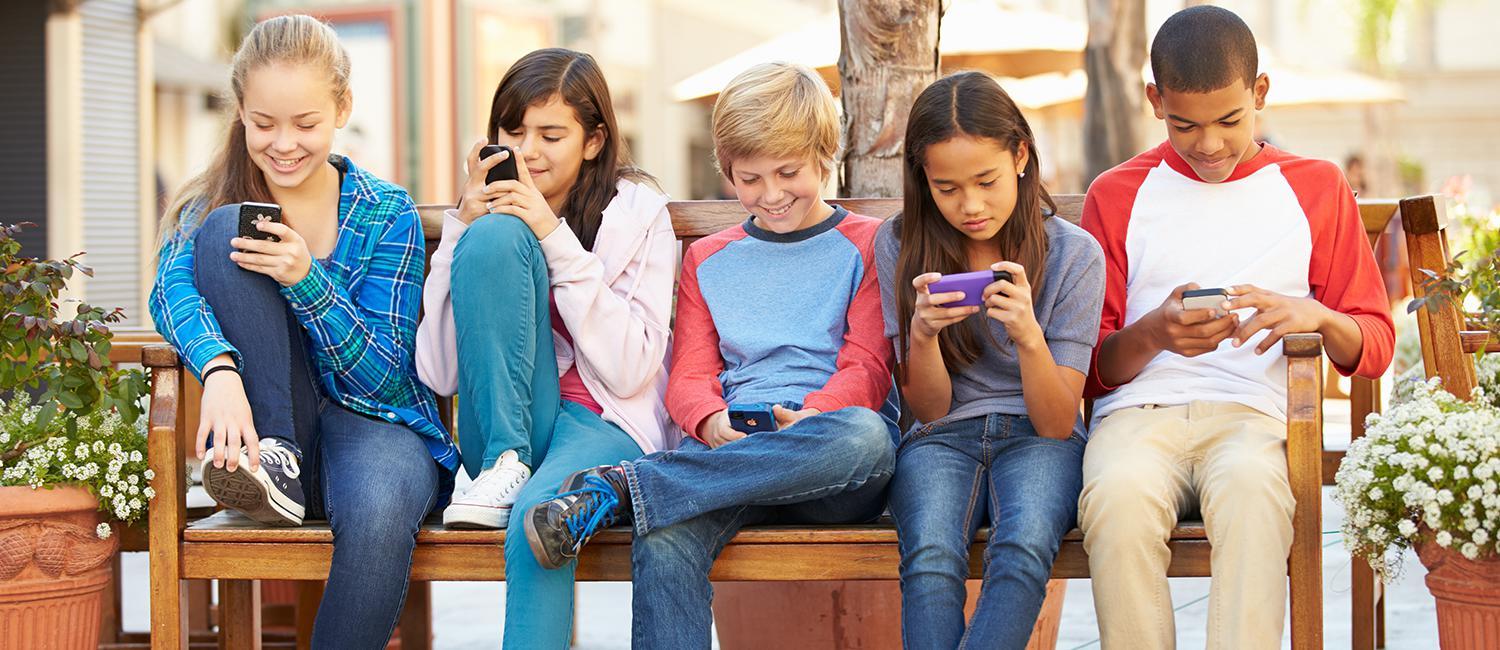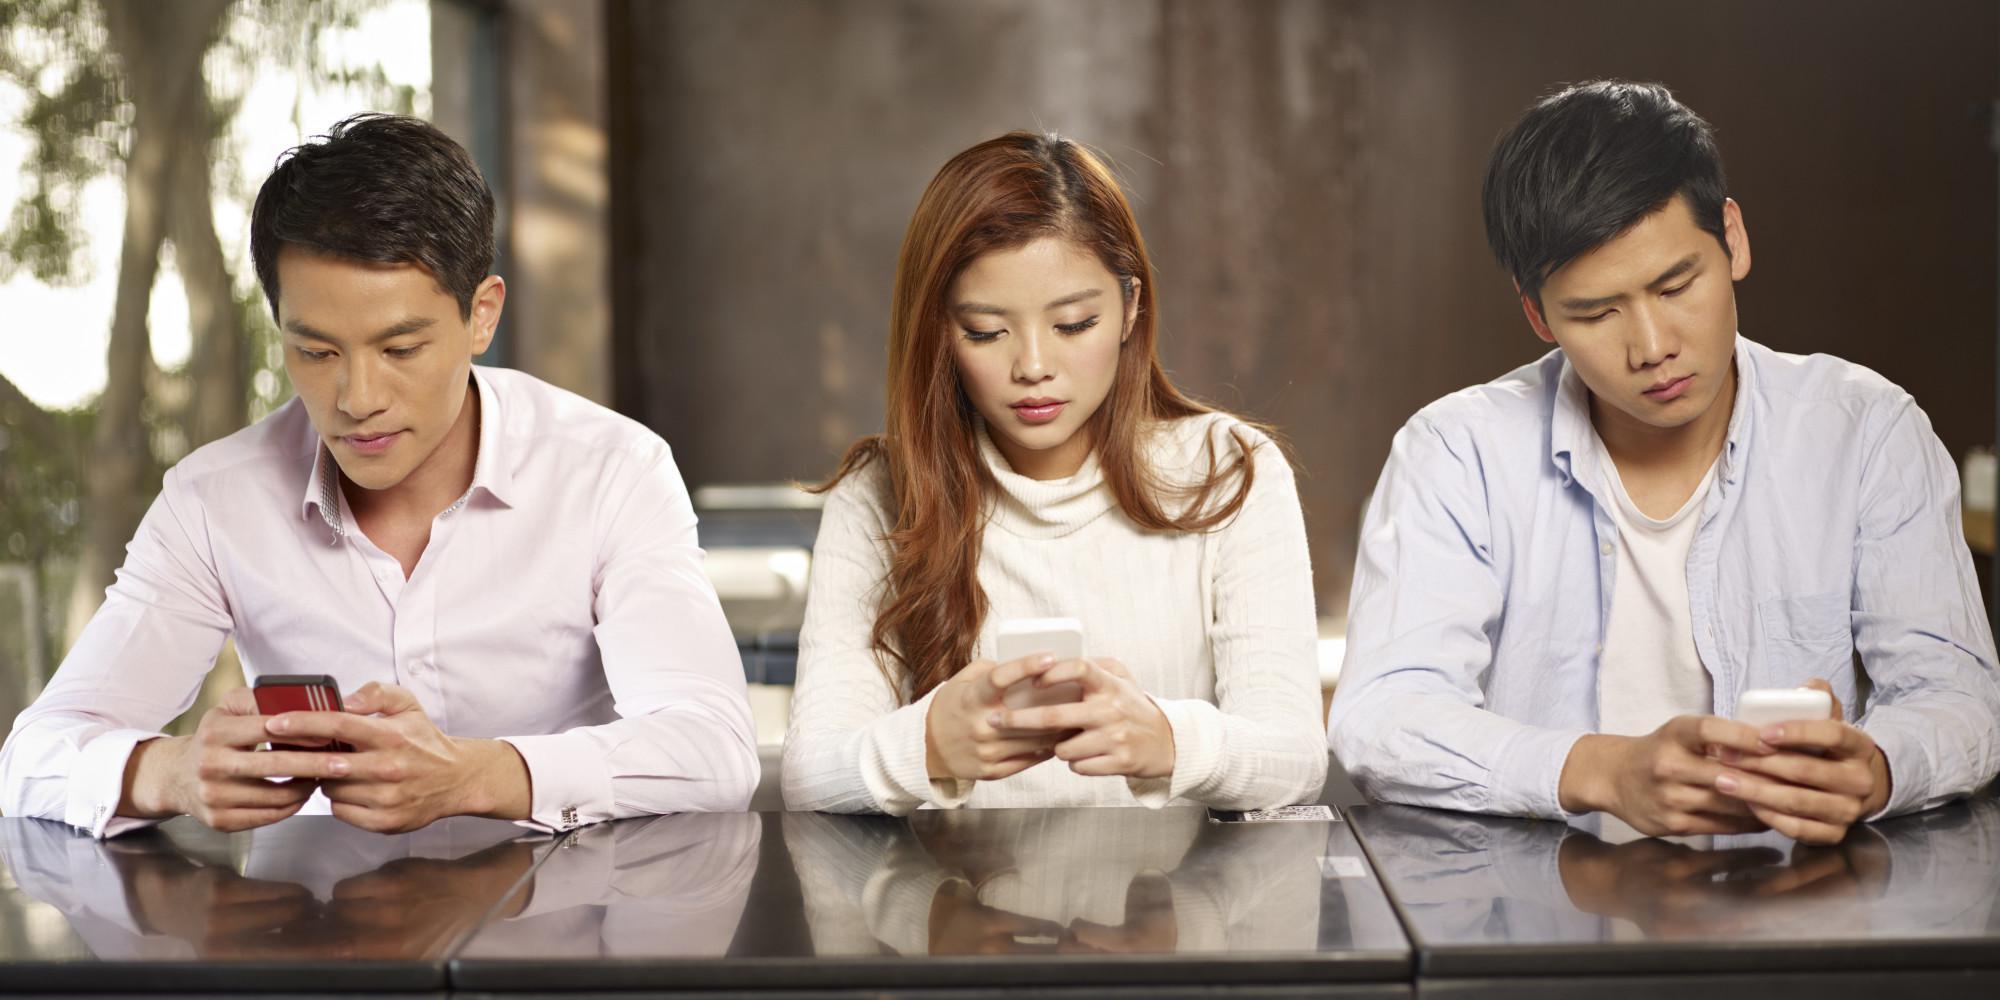The first image is the image on the left, the second image is the image on the right. For the images displayed, is the sentence "there are three people sitting at a shiny brown table looking at their phones, there are two men on the outside and a woman in the center" factually correct? Answer yes or no. Yes. The first image is the image on the left, the second image is the image on the right. For the images shown, is this caption "Three people are sitting together looking at their phones in the image on the right." true? Answer yes or no. Yes. 